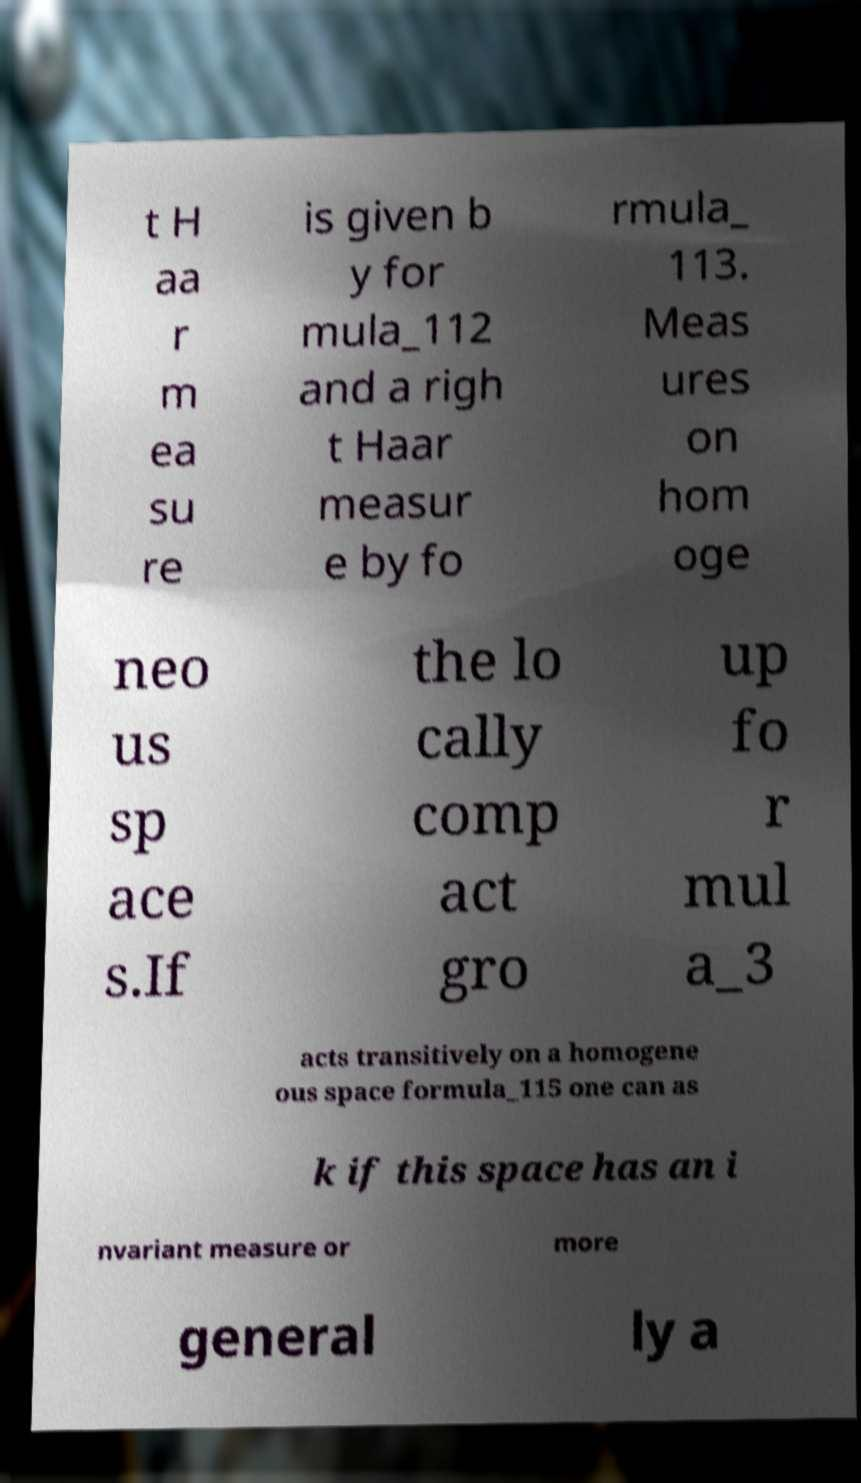Could you extract and type out the text from this image? t H aa r m ea su re is given b y for mula_112 and a righ t Haar measur e by fo rmula_ 113. Meas ures on hom oge neo us sp ace s.If the lo cally comp act gro up fo r mul a_3 acts transitively on a homogene ous space formula_115 one can as k if this space has an i nvariant measure or more general ly a 